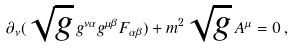<formula> <loc_0><loc_0><loc_500><loc_500>\partial _ { \nu } ( \sqrt { g } \, g ^ { \nu \alpha } g ^ { \mu \beta } F _ { \alpha \beta } ) + m ^ { 2 } \sqrt { g } \, A ^ { \mu } = 0 \, ,</formula> 